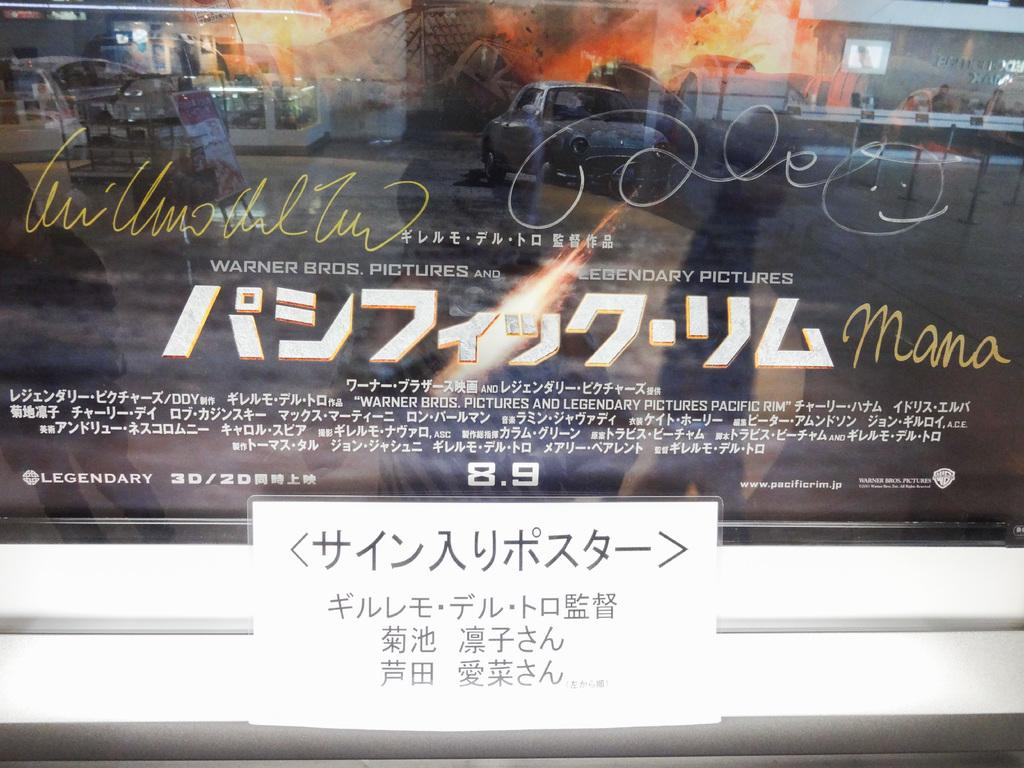What is on the glass in the image? There is a poster on the glass. What is located at the bottom of the image? There is a sign board at the bottom of the image. What can be seen in the reflection on the glass? The reflection in the glass shows cars, buildings, and fire. Who is the expert in the image? There is no expert present in the image. What type of skirt can be seen in the reflection on the glass? There is no skirt visible in the image; the reflection shows cars, buildings, and fire. 